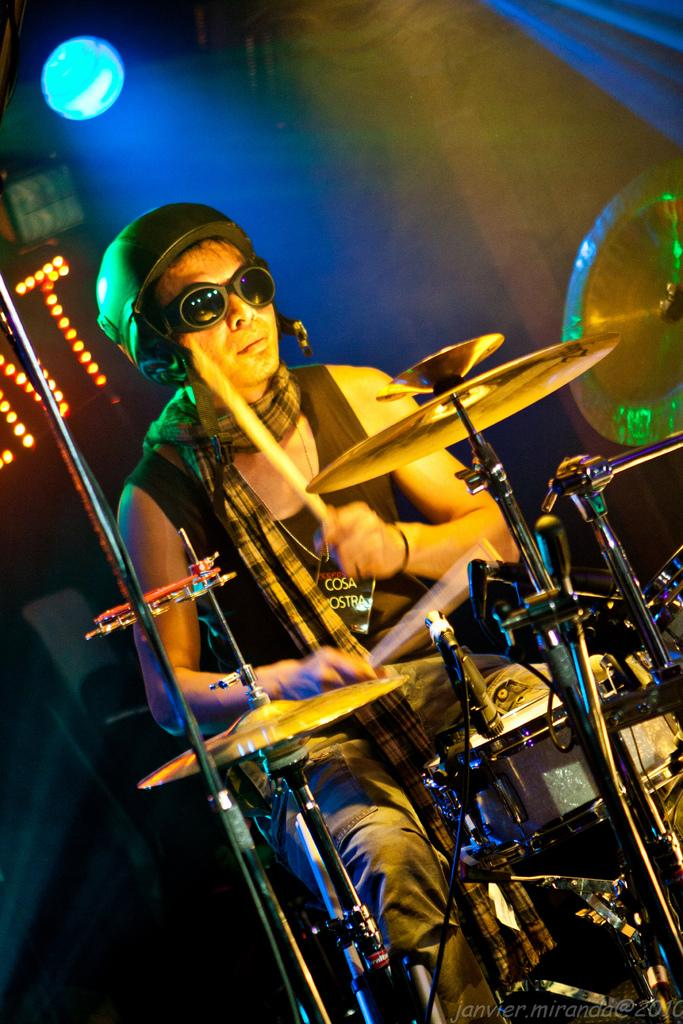What is the main subject of the image? There is a person in the image. What is the person doing in the image? The person is playing drums. What type of pan is being used to create steam in the image? There is no pan or steam present in the image; it features a person playing drums. 